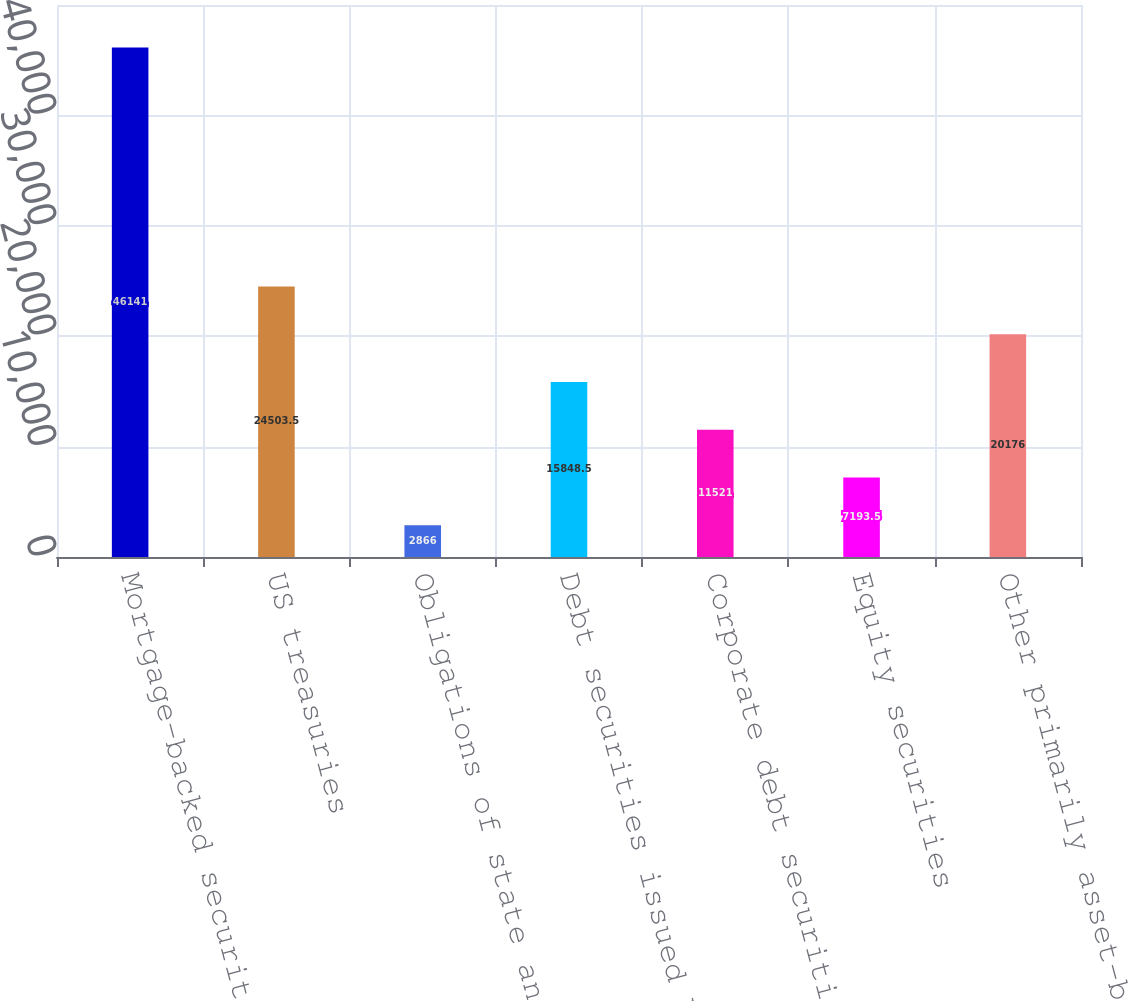Convert chart to OTSL. <chart><loc_0><loc_0><loc_500><loc_500><bar_chart><fcel>Mortgage-backed securities<fcel>US treasuries<fcel>Obligations of state and<fcel>Debt securities issued by<fcel>Corporate debt securities<fcel>Equity securities<fcel>Other primarily asset-backed<nl><fcel>46141<fcel>24503.5<fcel>2866<fcel>15848.5<fcel>11521<fcel>7193.5<fcel>20176<nl></chart> 